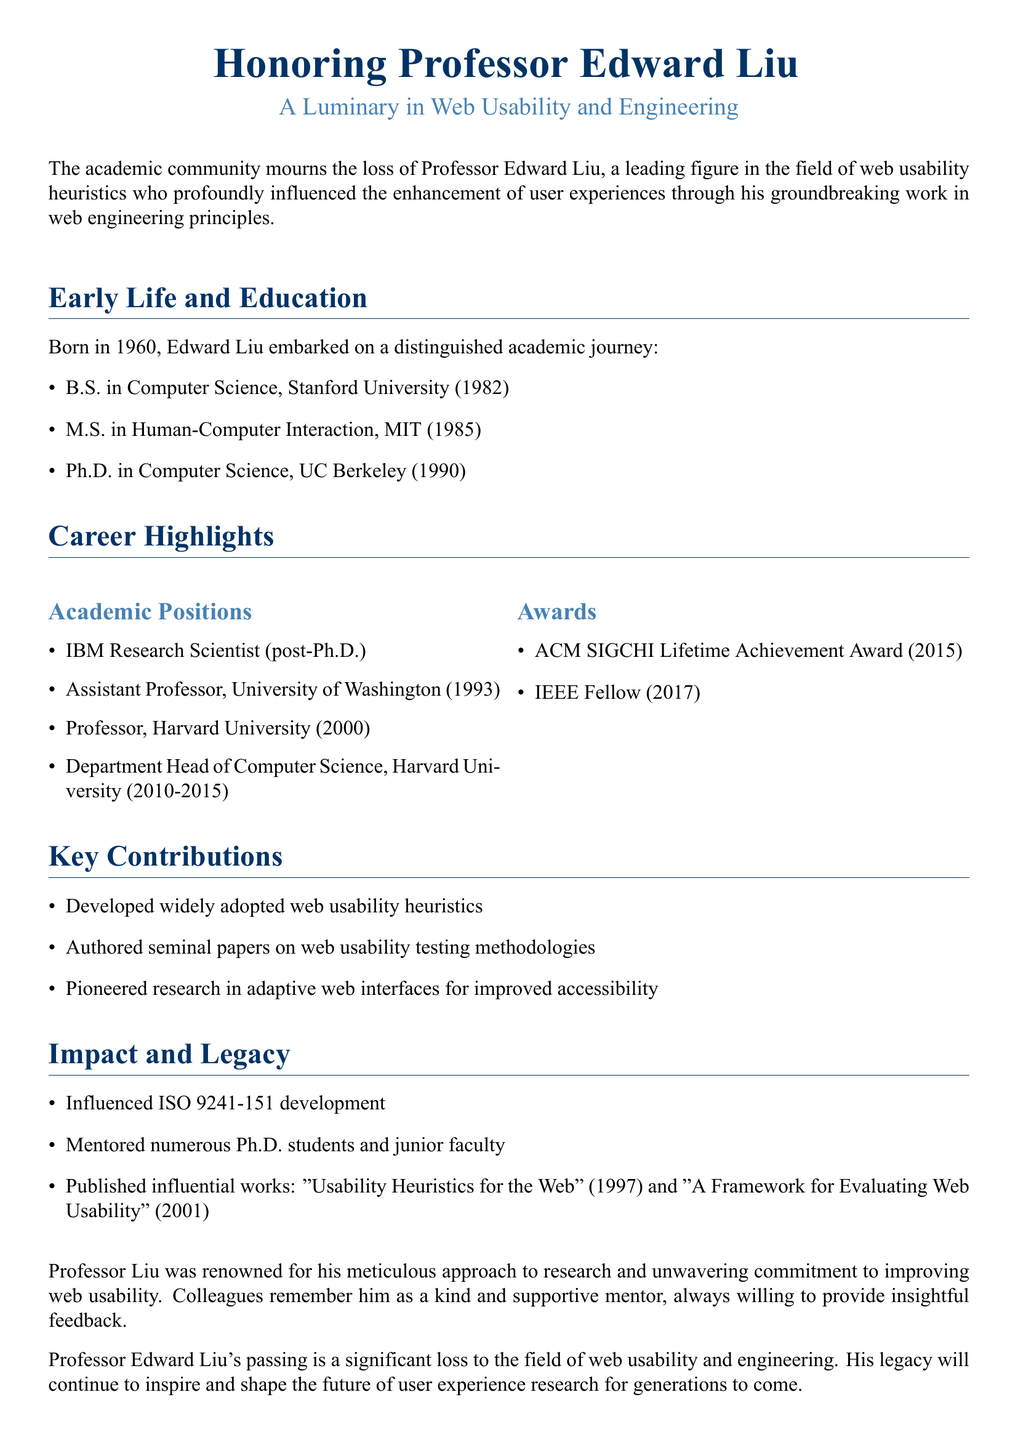What year was Edward Liu born? The document states the year of Edward Liu's birth as 1960.
Answer: 1960 What was the highest degree obtained by Edward Liu? The document lists his educational qualifications, indicating he earned a Ph.D. in Computer Science.
Answer: Ph.D Which university awarded Professor Liu the ACM SIGCHI Lifetime Achievement Award? The document specifically mentions he received this award in 2015.
Answer: 2015 What key contribution did Edward Liu make in web usability? The document details that he developed widely adopted web usability heuristics.
Answer: Usability heuristics How many Ph.D. students did Professor Liu mentor? The document states he mentored numerous Ph.D. students, although it does not specify a number.
Answer: Numerous In what year did Liu become a Professor at Harvard University? The document states that he became a Professor at Harvard University in 2000.
Answer: 2000 What publication is mentioned as authored by Edward Liu in 1997? The document lists "Usability Heuristics for the Web" as one of his influential works published in that year.
Answer: Usability Heuristics for the Web What is the significance of ISO 9241-151 in Professor Liu's legacy? The document indicates that he influenced its development, showcasing his impact in the field.
Answer: Influenced development 